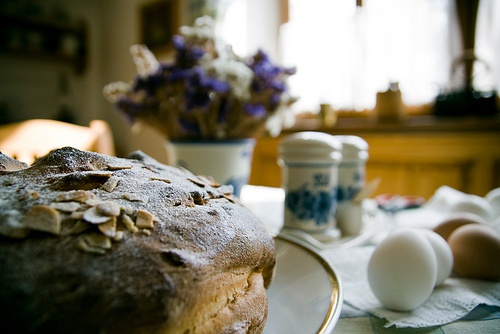Describe the objects in this image and their specific colors. I can see cake in black, darkgray, olive, and lightgray tones, potted plant in black, darkgray, gray, and lightgray tones, dining table in black, lightgray, darkgray, and gray tones, chair in black, ivory, and tan tones, and vase in black, gray, darkgray, and lightgray tones in this image. 